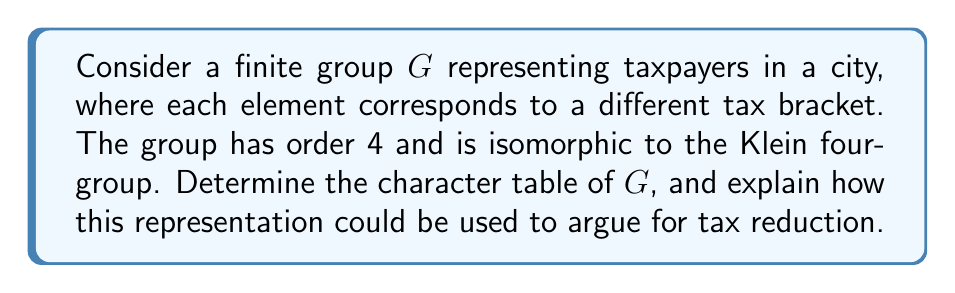What is the answer to this math problem? 1) First, let's identify the conjugacy classes of $G$. Since $G$ is isomorphic to the Klein four-group, it has the structure $C_2 \times C_2$. All elements are self-inverse, and the group is abelian, so each element forms its own conjugacy class. Let's denote the elements as $\{e, a, b, c\}$.

2) The number of irreducible representations is equal to the number of conjugacy classes, which is 4.

3) For an abelian group, all irreducible representations are one-dimensional. Therefore, all characters are homomorphisms from $G$ to $\mathbb{C}^*$.

4) We can construct the character table as follows:
   - $\chi_1$ is the trivial representation, mapping all elements to 1.
   - $\chi_2(e) = 1, \chi_2(a) = -1, \chi_2(b) = 1, \chi_2(c) = -1$
   - $\chi_3(e) = 1, \chi_3(a) = 1, \chi_3(b) = -1, \chi_3(c) = -1$
   - $\chi_4(e) = 1, \chi_4(a) = -1, \chi_4(b) = -1, \chi_4(c) = 1$

5) The character table is:

$$
\begin{array}{c|cccc}
G & e & a & b & c \\
\hline
\chi_1 & 1 & 1 & 1 & 1 \\
\chi_2 & 1 & -1 & 1 & -1 \\
\chi_3 & 1 & 1 & -1 & -1 \\
\chi_4 & 1 & -1 & -1 & 1
\end{array}
$$

6) To argue for tax reduction:
   - Each character represents a different way taxpayers respond to tax policies.
   - $\chi_1$ represents uniform response across all brackets (e.g., all oppose high taxes).
   - $\chi_2, \chi_3, \chi_4$ show varying responses in different brackets.
   - The presence of -1 values indicates potential negative economic impacts in certain brackets.
   - A fiscal conservative could argue that the varied responses (represented by different characters) show that current tax policies are creating economic inefficiencies, and a simpler, lower tax system would lead to more uniform, positive responses across all brackets.
Answer: Character table of $G$:
$$
\begin{array}{c|cccc}
G & e & a & b & c \\
\hline
\chi_1 & 1 & 1 & 1 & 1 \\
\chi_2 & 1 & -1 & 1 & -1 \\
\chi_3 & 1 & 1 & -1 & -1 \\
\chi_4 & 1 & -1 & -1 & 1
\end{array}
$$ 